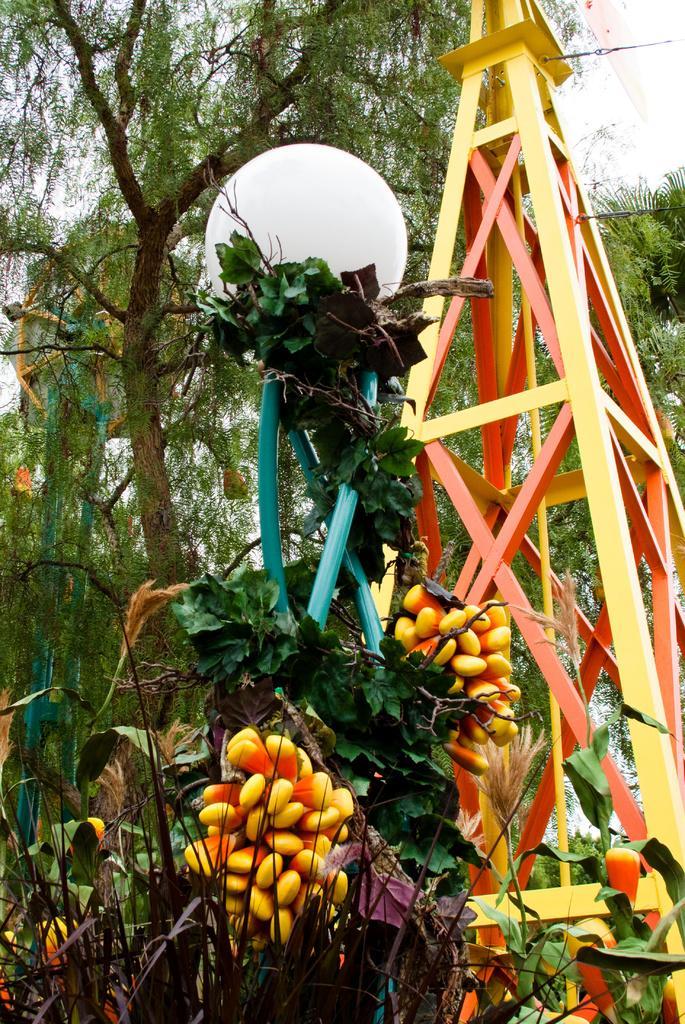In one or two sentences, can you explain what this image depicts? In this image there is a metal structure, in front of the metal structure there is a plastic tree with fruits and lamp on it, behind the metal structure there is a tree. 